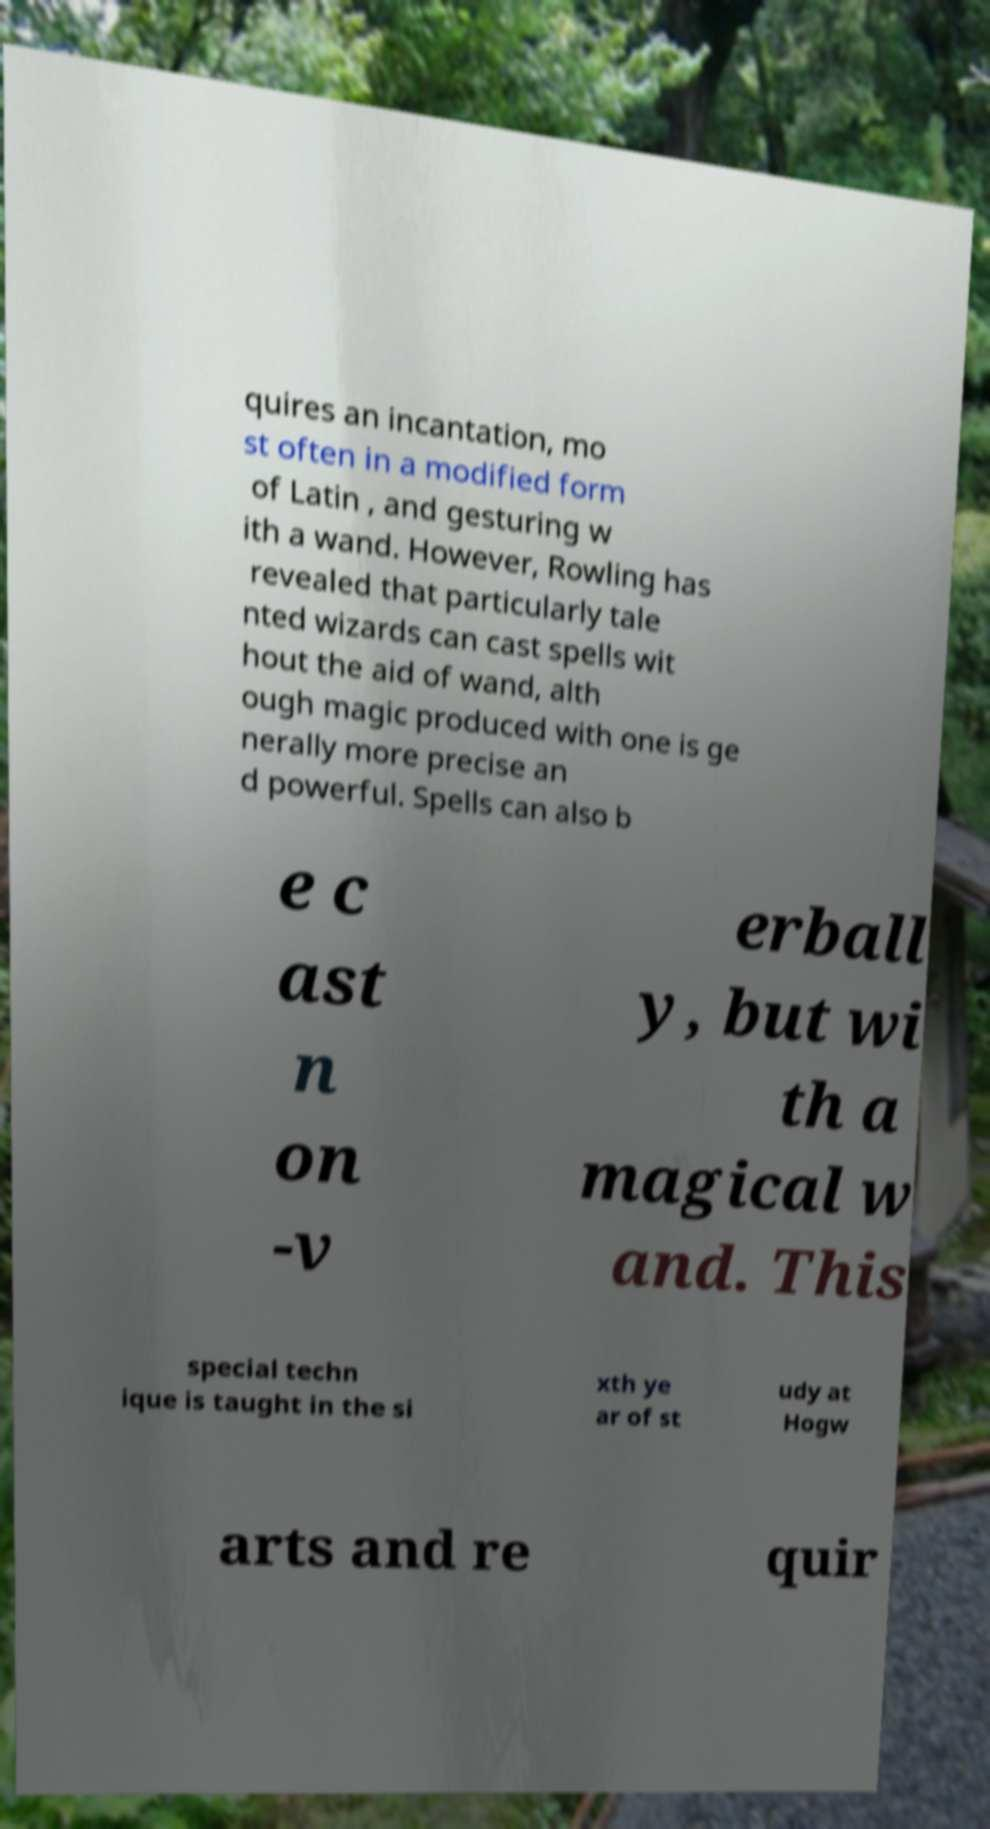There's text embedded in this image that I need extracted. Can you transcribe it verbatim? quires an incantation, mo st often in a modified form of Latin , and gesturing w ith a wand. However, Rowling has revealed that particularly tale nted wizards can cast spells wit hout the aid of wand, alth ough magic produced with one is ge nerally more precise an d powerful. Spells can also b e c ast n on -v erball y, but wi th a magical w and. This special techn ique is taught in the si xth ye ar of st udy at Hogw arts and re quir 